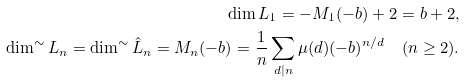<formula> <loc_0><loc_0><loc_500><loc_500>\dim L _ { 1 } = - M _ { 1 } ( - b ) + 2 = b + 2 , \\ \dim ^ { \sim } L _ { n } = \dim ^ { \sim } \hat { L } _ { n } = M _ { n } ( - b ) = \frac { 1 } { n } \sum _ { d | n } \mu ( d ) ( - b ) ^ { n / d } \quad ( n \geq 2 ) .</formula> 